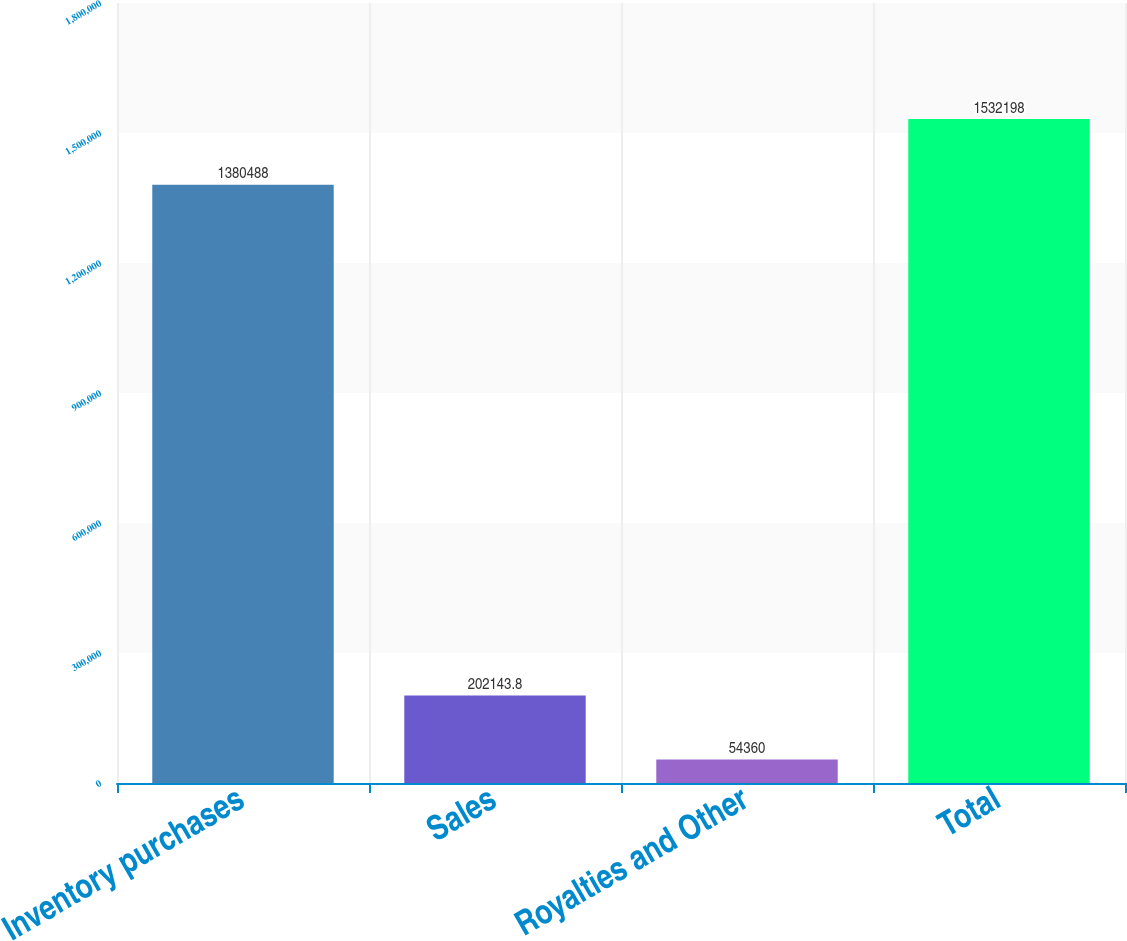Convert chart to OTSL. <chart><loc_0><loc_0><loc_500><loc_500><bar_chart><fcel>Inventory purchases<fcel>Sales<fcel>Royalties and Other<fcel>Total<nl><fcel>1.38049e+06<fcel>202144<fcel>54360<fcel>1.5322e+06<nl></chart> 